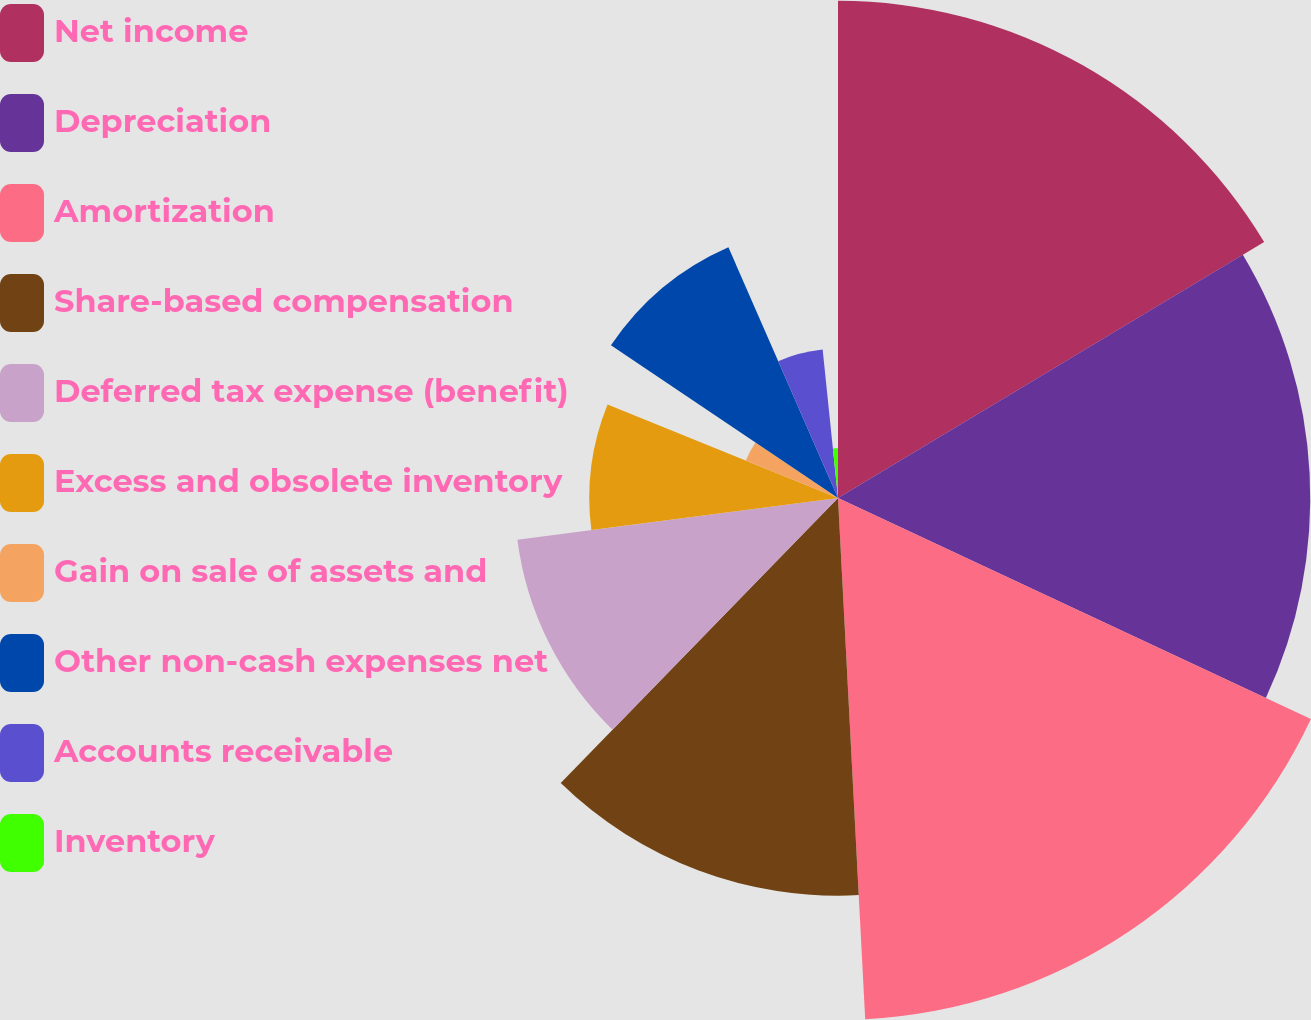<chart> <loc_0><loc_0><loc_500><loc_500><pie_chart><fcel>Net income<fcel>Depreciation<fcel>Amortization<fcel>Share-based compensation<fcel>Deferred tax expense (benefit)<fcel>Excess and obsolete inventory<fcel>Gain on sale of assets and<fcel>Other non-cash expenses net<fcel>Accounts receivable<fcel>Inventory<nl><fcel>16.39%<fcel>15.57%<fcel>17.21%<fcel>13.11%<fcel>10.66%<fcel>8.2%<fcel>3.28%<fcel>9.02%<fcel>4.92%<fcel>1.64%<nl></chart> 